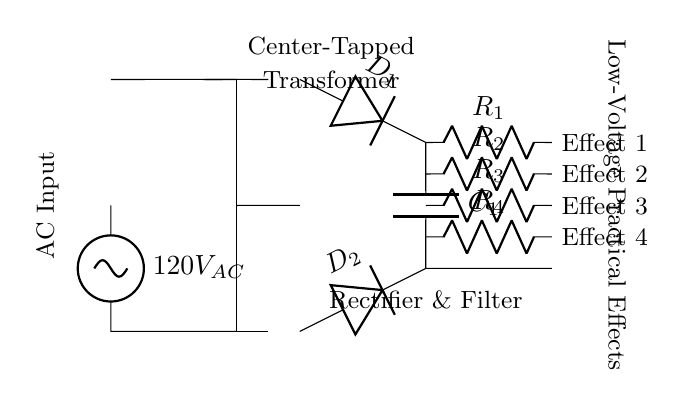What is the input voltage of the circuit? The input voltage is labeled as 120V AC, which is indicated near the AC source in the circuit diagram.
Answer: 120V AC How many diodes are in the rectifier? There are two diodes in the circuit, named D1 and D2, which can be seen connected to the center-tapped transformer.
Answer: Two What does the smoothing capacitor do? The smoothing capacitor, labeled C1 in the circuit, is used to reduce the voltage ripple in the rectified output by storing and releasing charge.
Answer: Reduces ripple What are the load resistors connected to? The load resistors, labeled R1, R2, R3, and R4, are connected to the output of the smoothing capacitor, allowing them to power multiple effects simultaneously.
Answer: Smoothing capacitor How many practical effects can be powered by this circuit? The circuit can power four separate practical effects, indicated by the four load resistors connected at the output.
Answer: Four What type of transformer is used in this circuit? The transformer used in the circuit is a center-tapped transformer, which is specifically indicated by its labeling in the diagram.
Answer: Center-tapped Explain why a center-tapped transformer is used in the rectifier. A center-tapped transformer provides two equal voltages from the center tap, allowing the circuit to use both halves of the AC waveform for rectification, improving efficiency and voltage output.
Answer: To improve efficiency 